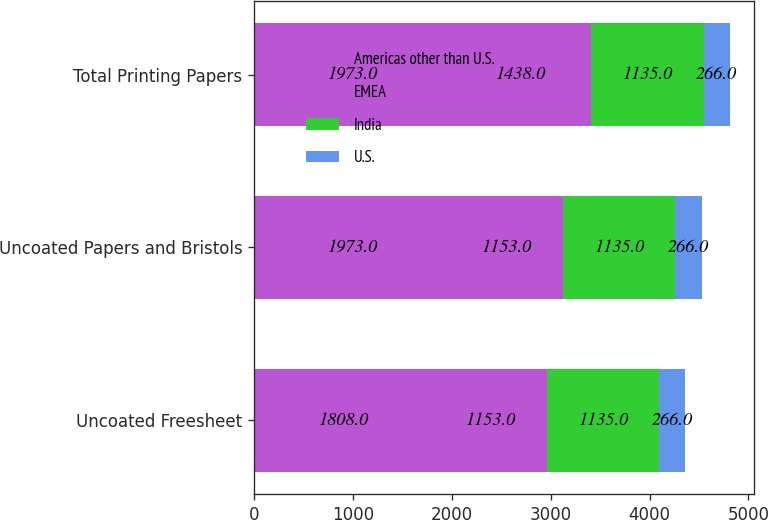Convert chart. <chart><loc_0><loc_0><loc_500><loc_500><stacked_bar_chart><ecel><fcel>Uncoated Freesheet<fcel>Uncoated Papers and Bristols<fcel>Total Printing Papers<nl><fcel>Americas other than U.S.<fcel>1808<fcel>1973<fcel>1973<nl><fcel>EMEA<fcel>1153<fcel>1153<fcel>1438<nl><fcel>India<fcel>1135<fcel>1135<fcel>1135<nl><fcel>U.S.<fcel>266<fcel>266<fcel>266<nl></chart> 